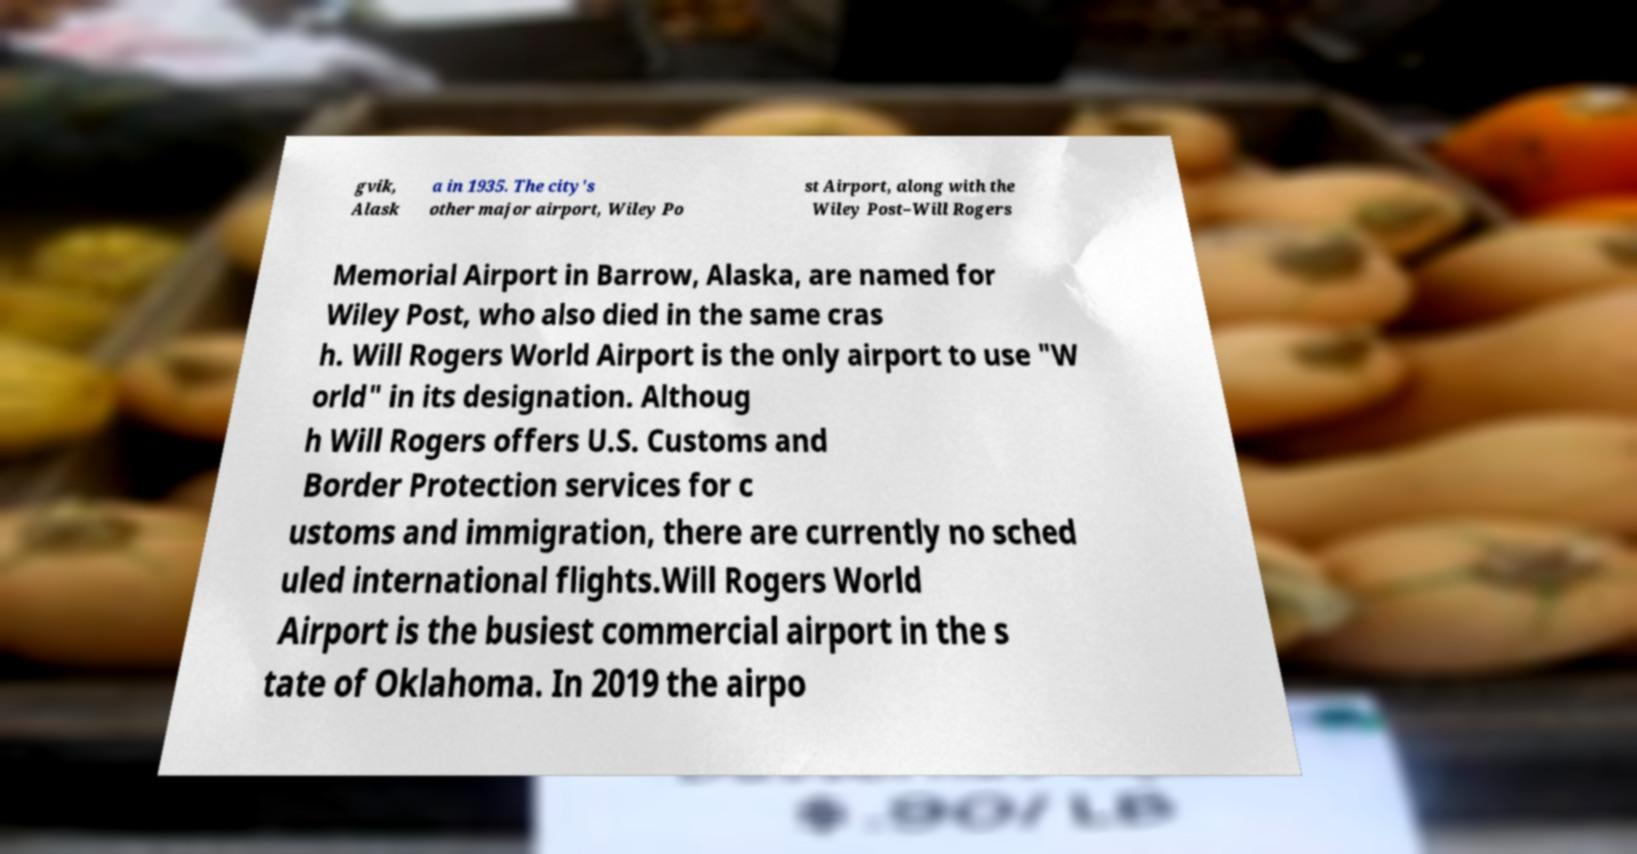There's text embedded in this image that I need extracted. Can you transcribe it verbatim? gvik, Alask a in 1935. The city's other major airport, Wiley Po st Airport, along with the Wiley Post–Will Rogers Memorial Airport in Barrow, Alaska, are named for Wiley Post, who also died in the same cras h. Will Rogers World Airport is the only airport to use "W orld" in its designation. Althoug h Will Rogers offers U.S. Customs and Border Protection services for c ustoms and immigration, there are currently no sched uled international flights.Will Rogers World Airport is the busiest commercial airport in the s tate of Oklahoma. In 2019 the airpo 